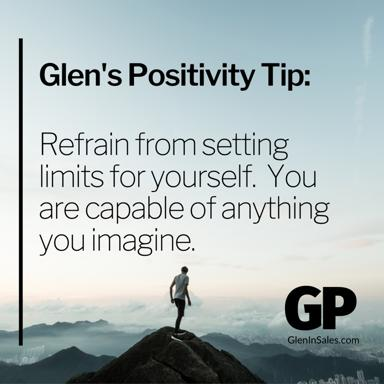How does the lighting in the image contribute to its overall message? The lighting in the image, particularly the bright light seen illuminating the figure and the mountain peak, serves to enhance the feeling of enlightenment and victory. It emphasizes the breakthrough and clarity that comes with reaching one's highest goals, metaphorically shining light on what can be achieved when one does not restrict their own potential. This visual element underlines the uplifting spirit of Glen’s Positivity Tip. 